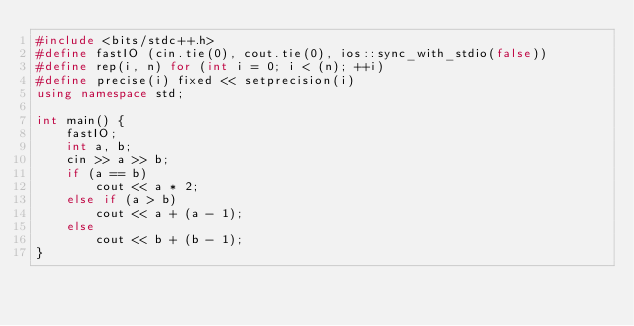<code> <loc_0><loc_0><loc_500><loc_500><_C++_>#include <bits/stdc++.h>
#define fastIO (cin.tie(0), cout.tie(0), ios::sync_with_stdio(false))
#define rep(i, n) for (int i = 0; i < (n); ++i)
#define precise(i) fixed << setprecision(i)
using namespace std;

int main() {
    fastIO;
    int a, b;
    cin >> a >> b;
    if (a == b)
        cout << a * 2;
    else if (a > b)
        cout << a + (a - 1);
    else
        cout << b + (b - 1);
}</code> 